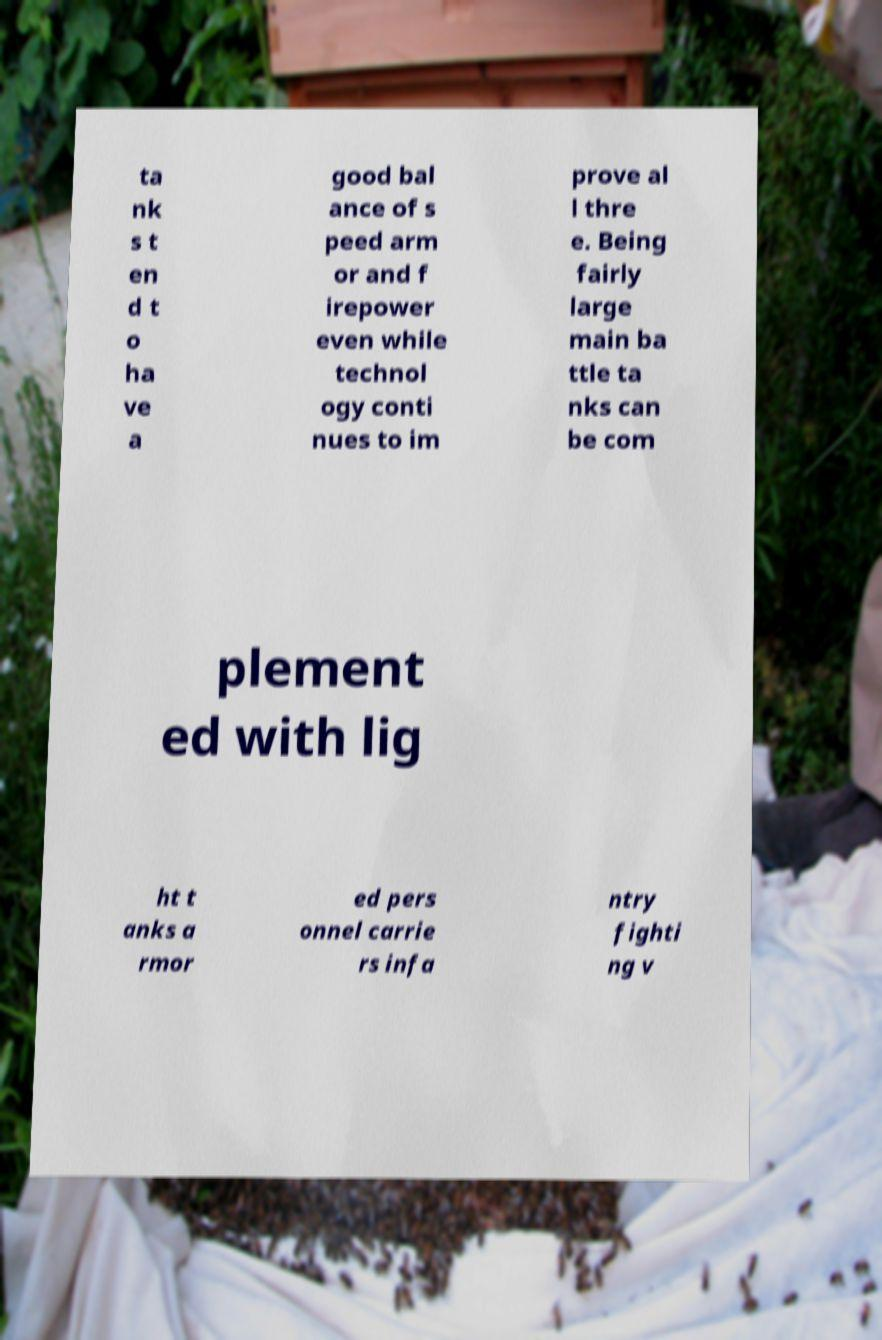Could you assist in decoding the text presented in this image and type it out clearly? ta nk s t en d t o ha ve a good bal ance of s peed arm or and f irepower even while technol ogy conti nues to im prove al l thre e. Being fairly large main ba ttle ta nks can be com plement ed with lig ht t anks a rmor ed pers onnel carrie rs infa ntry fighti ng v 